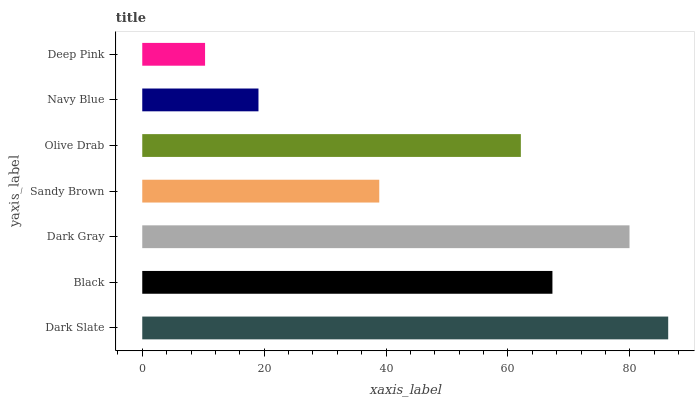Is Deep Pink the minimum?
Answer yes or no. Yes. Is Dark Slate the maximum?
Answer yes or no. Yes. Is Black the minimum?
Answer yes or no. No. Is Black the maximum?
Answer yes or no. No. Is Dark Slate greater than Black?
Answer yes or no. Yes. Is Black less than Dark Slate?
Answer yes or no. Yes. Is Black greater than Dark Slate?
Answer yes or no. No. Is Dark Slate less than Black?
Answer yes or no. No. Is Olive Drab the high median?
Answer yes or no. Yes. Is Olive Drab the low median?
Answer yes or no. Yes. Is Navy Blue the high median?
Answer yes or no. No. Is Black the low median?
Answer yes or no. No. 